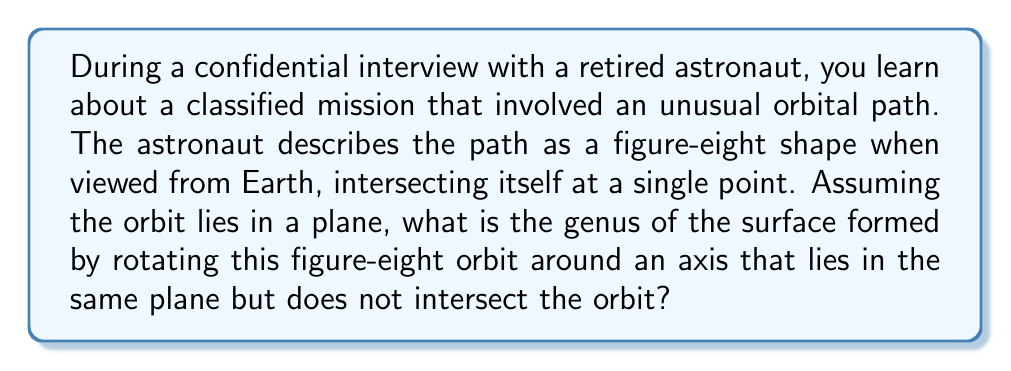Teach me how to tackle this problem. To solve this problem, we need to apply concepts from topology and consider the following steps:

1) First, let's visualize the orbit. The figure-eight shape is topologically equivalent to a "lemniscate" curve.

2) When we rotate this figure-eight around an axis in its plane (that doesn't intersect the curve), we're creating a surface of revolution.

3) The resulting surface will have a hole for each "loop" of the figure-eight. This is because each loop, when rotated, creates a torus-like structure.

4) However, these two torus-like structures intersect at the self-intersection point of the figure-eight. This intersection creates a singularity in the surface.

5) To determine the genus, we need to count the number of "holes" in the surface. In this case:
   - We have two holes from the two loops of the figure-eight
   - The self-intersection doesn't create or remove any holes

6) Therefore, the genus of this surface is 2.

This can be verified using the Euler characteristic $\chi = 2 - 2g$, where $g$ is the genus. For a surface with two holes, $\chi = -2$, which gives us:

$$-2 = 2 - 2g$$
$$2g = 4$$
$$g = 2$$

This unusual orbital path creates a surface that is topologically equivalent to a two-holed torus, also known as a double torus or 2-torus.
Answer: The genus of the surface formed by rotating the figure-eight orbit is 2. 